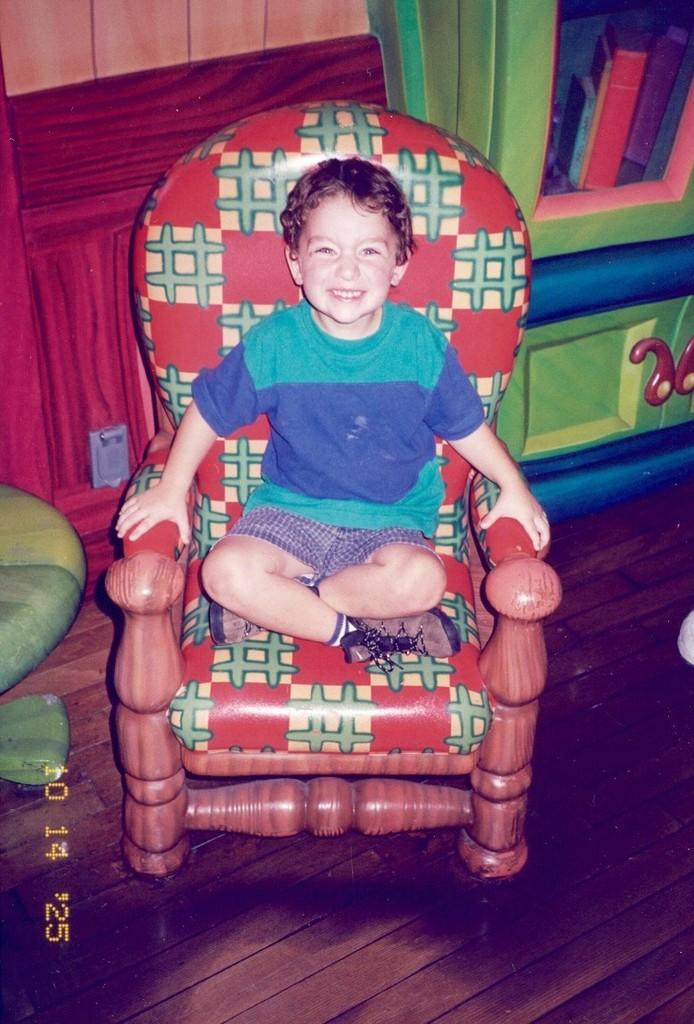What is the main subject of the image? The main subject of the image is a child. Where is the child located in the image? The child is sitting on a sofa chair in the image. What is the child wearing in the image? The child is wearing a green and blue color t-shirt and shorts in the image. What type of bead is hanging from the child's collar in the image? There is no bead or collar present on the child in the image. What type of home is visible in the background of the image? The image does not show a home or any background; it only features the child sitting on a sofa chair. 